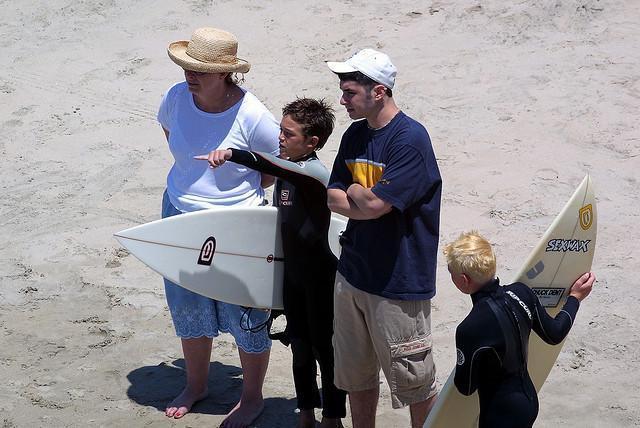How many children are in the image?
Give a very brief answer. 2. How many people are dressed for surfing?
Give a very brief answer. 2. How many people are in the picture?
Give a very brief answer. 4. How many surfboards are there?
Give a very brief answer. 2. How many silver cars are in the image?
Give a very brief answer. 0. 